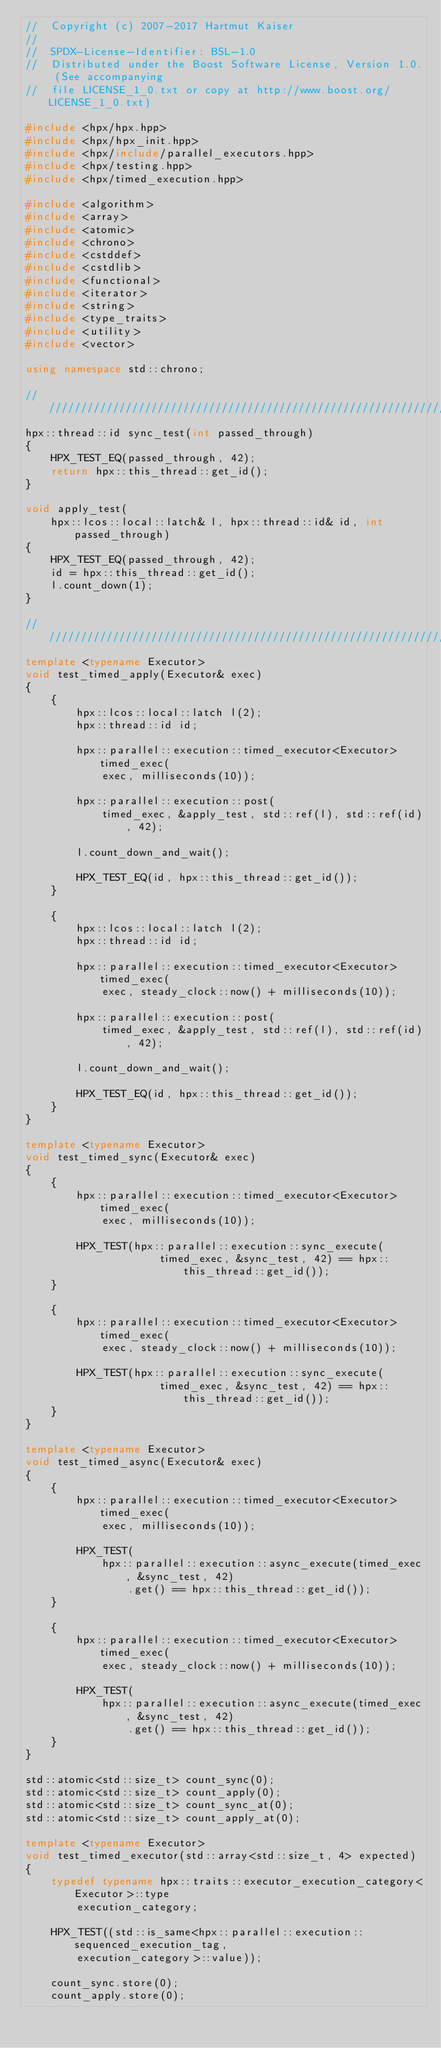<code> <loc_0><loc_0><loc_500><loc_500><_C++_>//  Copyright (c) 2007-2017 Hartmut Kaiser
//
//  SPDX-License-Identifier: BSL-1.0
//  Distributed under the Boost Software License, Version 1.0. (See accompanying
//  file LICENSE_1_0.txt or copy at http://www.boost.org/LICENSE_1_0.txt)

#include <hpx/hpx.hpp>
#include <hpx/hpx_init.hpp>
#include <hpx/include/parallel_executors.hpp>
#include <hpx/testing.hpp>
#include <hpx/timed_execution.hpp>

#include <algorithm>
#include <array>
#include <atomic>
#include <chrono>
#include <cstddef>
#include <cstdlib>
#include <functional>
#include <iterator>
#include <string>
#include <type_traits>
#include <utility>
#include <vector>

using namespace std::chrono;

///////////////////////////////////////////////////////////////////////////////
hpx::thread::id sync_test(int passed_through)
{
    HPX_TEST_EQ(passed_through, 42);
    return hpx::this_thread::get_id();
}

void apply_test(
    hpx::lcos::local::latch& l, hpx::thread::id& id, int passed_through)
{
    HPX_TEST_EQ(passed_through, 42);
    id = hpx::this_thread::get_id();
    l.count_down(1);
}

///////////////////////////////////////////////////////////////////////////////
template <typename Executor>
void test_timed_apply(Executor& exec)
{
    {
        hpx::lcos::local::latch l(2);
        hpx::thread::id id;

        hpx::parallel::execution::timed_executor<Executor> timed_exec(
            exec, milliseconds(10));

        hpx::parallel::execution::post(
            timed_exec, &apply_test, std::ref(l), std::ref(id), 42);

        l.count_down_and_wait();

        HPX_TEST_EQ(id, hpx::this_thread::get_id());
    }

    {
        hpx::lcos::local::latch l(2);
        hpx::thread::id id;

        hpx::parallel::execution::timed_executor<Executor> timed_exec(
            exec, steady_clock::now() + milliseconds(10));

        hpx::parallel::execution::post(
            timed_exec, &apply_test, std::ref(l), std::ref(id), 42);

        l.count_down_and_wait();

        HPX_TEST_EQ(id, hpx::this_thread::get_id());
    }
}

template <typename Executor>
void test_timed_sync(Executor& exec)
{
    {
        hpx::parallel::execution::timed_executor<Executor> timed_exec(
            exec, milliseconds(10));

        HPX_TEST(hpx::parallel::execution::sync_execute(
                     timed_exec, &sync_test, 42) == hpx::this_thread::get_id());
    }

    {
        hpx::parallel::execution::timed_executor<Executor> timed_exec(
            exec, steady_clock::now() + milliseconds(10));

        HPX_TEST(hpx::parallel::execution::sync_execute(
                     timed_exec, &sync_test, 42) == hpx::this_thread::get_id());
    }
}

template <typename Executor>
void test_timed_async(Executor& exec)
{
    {
        hpx::parallel::execution::timed_executor<Executor> timed_exec(
            exec, milliseconds(10));

        HPX_TEST(
            hpx::parallel::execution::async_execute(timed_exec, &sync_test, 42)
                .get() == hpx::this_thread::get_id());
    }

    {
        hpx::parallel::execution::timed_executor<Executor> timed_exec(
            exec, steady_clock::now() + milliseconds(10));

        HPX_TEST(
            hpx::parallel::execution::async_execute(timed_exec, &sync_test, 42)
                .get() == hpx::this_thread::get_id());
    }
}

std::atomic<std::size_t> count_sync(0);
std::atomic<std::size_t> count_apply(0);
std::atomic<std::size_t> count_sync_at(0);
std::atomic<std::size_t> count_apply_at(0);

template <typename Executor>
void test_timed_executor(std::array<std::size_t, 4> expected)
{
    typedef typename hpx::traits::executor_execution_category<Executor>::type
        execution_category;

    HPX_TEST((std::is_same<hpx::parallel::execution::sequenced_execution_tag,
        execution_category>::value));

    count_sync.store(0);
    count_apply.store(0);</code> 